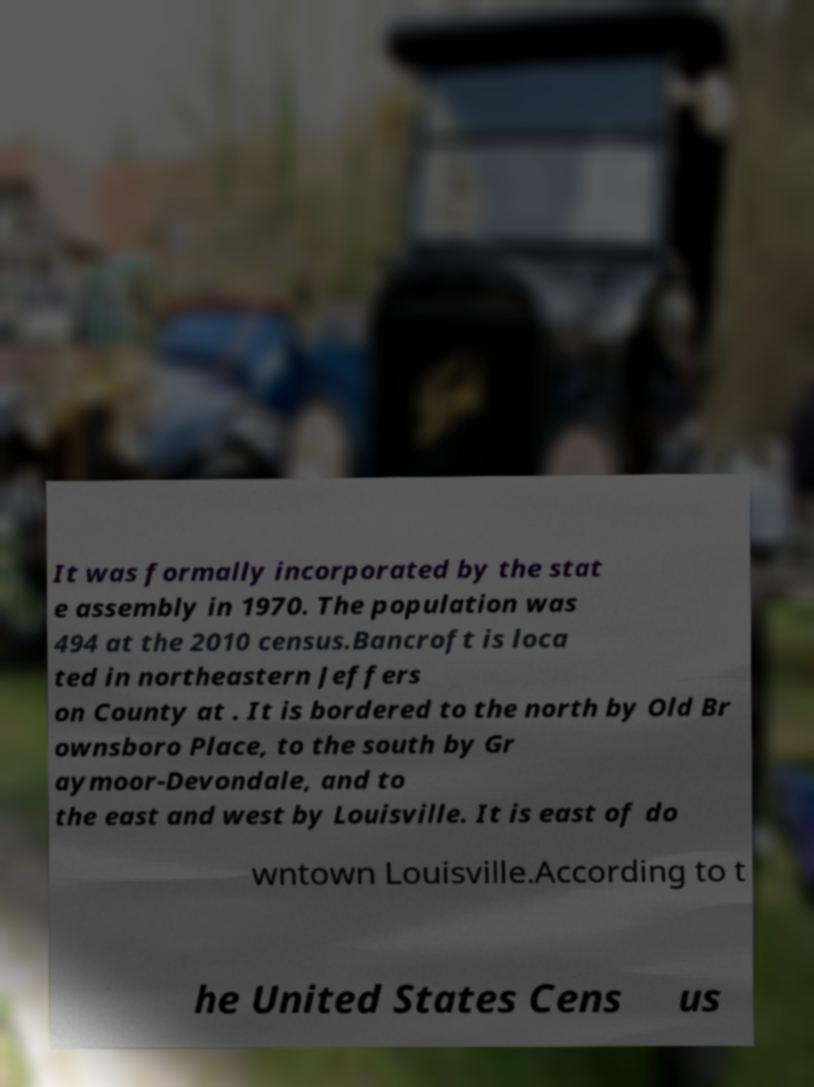Could you assist in decoding the text presented in this image and type it out clearly? It was formally incorporated by the stat e assembly in 1970. The population was 494 at the 2010 census.Bancroft is loca ted in northeastern Jeffers on County at . It is bordered to the north by Old Br ownsboro Place, to the south by Gr aymoor-Devondale, and to the east and west by Louisville. It is east of do wntown Louisville.According to t he United States Cens us 